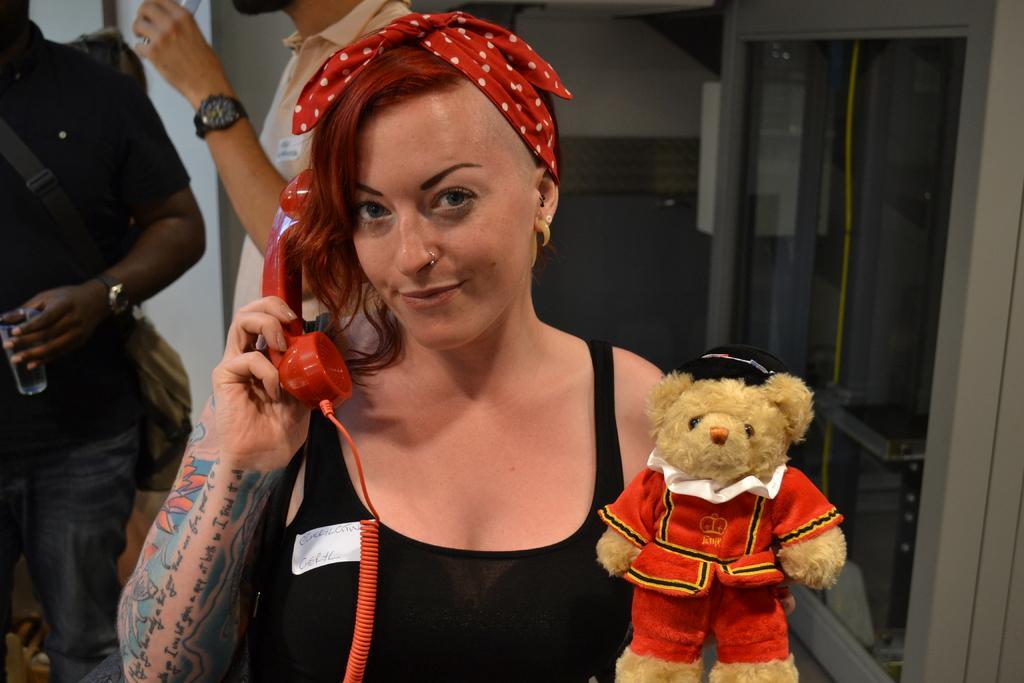Could you give a brief overview of what you see in this image? In this image I can see a person holding a telephone receiver. There is a toy and there are two other persons in the background holding glasses, also there are some other objects. 